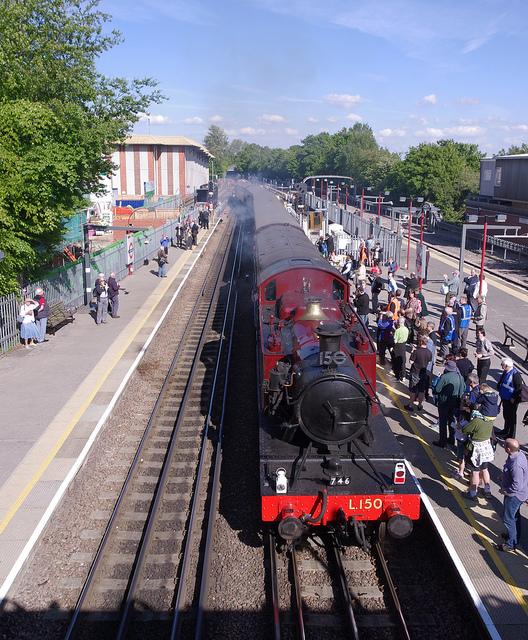Is this a train station?
Answer briefly. Yes. What number of tracks are between the people?
Short answer required. 2. What are waiting outside the train?
Be succinct. People. What color is the train?
Short answer required. Red. Is the train coming to a stop?
Concise answer only. Yes. 